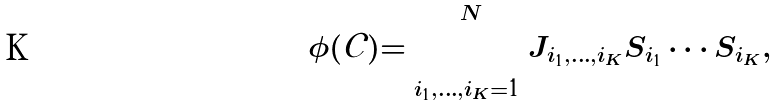<formula> <loc_0><loc_0><loc_500><loc_500>\phi ( \mathcal { C } ) = \sum _ { i _ { 1 } , \dots , i _ { K } = 1 } ^ { N } J _ { i _ { 1 } , \dots , i _ { K } } S _ { i _ { 1 } } \cdots S _ { i _ { K } } ,</formula> 